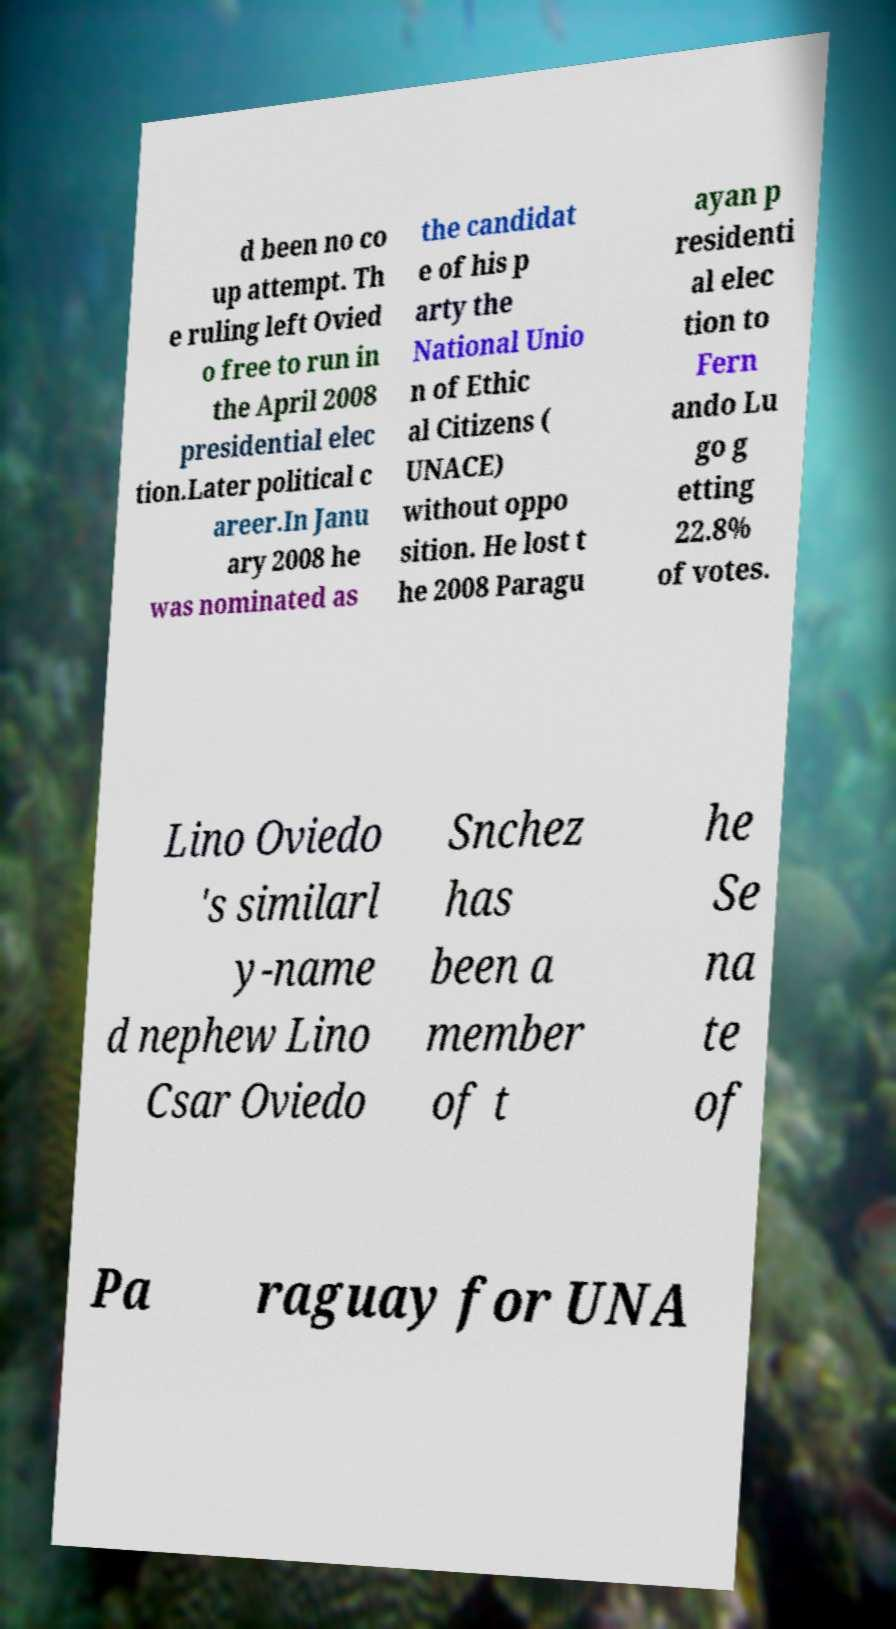I need the written content from this picture converted into text. Can you do that? d been no co up attempt. Th e ruling left Ovied o free to run in the April 2008 presidential elec tion.Later political c areer.In Janu ary 2008 he was nominated as the candidat e of his p arty the National Unio n of Ethic al Citizens ( UNACE) without oppo sition. He lost t he 2008 Paragu ayan p residenti al elec tion to Fern ando Lu go g etting 22.8% of votes. Lino Oviedo 's similarl y-name d nephew Lino Csar Oviedo Snchez has been a member of t he Se na te of Pa raguay for UNA 